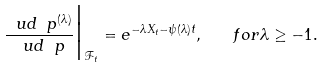Convert formula to latex. <formula><loc_0><loc_0><loc_500><loc_500>\frac { \ u d \ p ^ { ( \lambda ) } } { \ u d \ p } \Big | _ { \mathcal { F } _ { t } } = e ^ { - \lambda X _ { t } - \psi ( \lambda ) t } , \quad f o r \lambda \geq - 1 .</formula> 